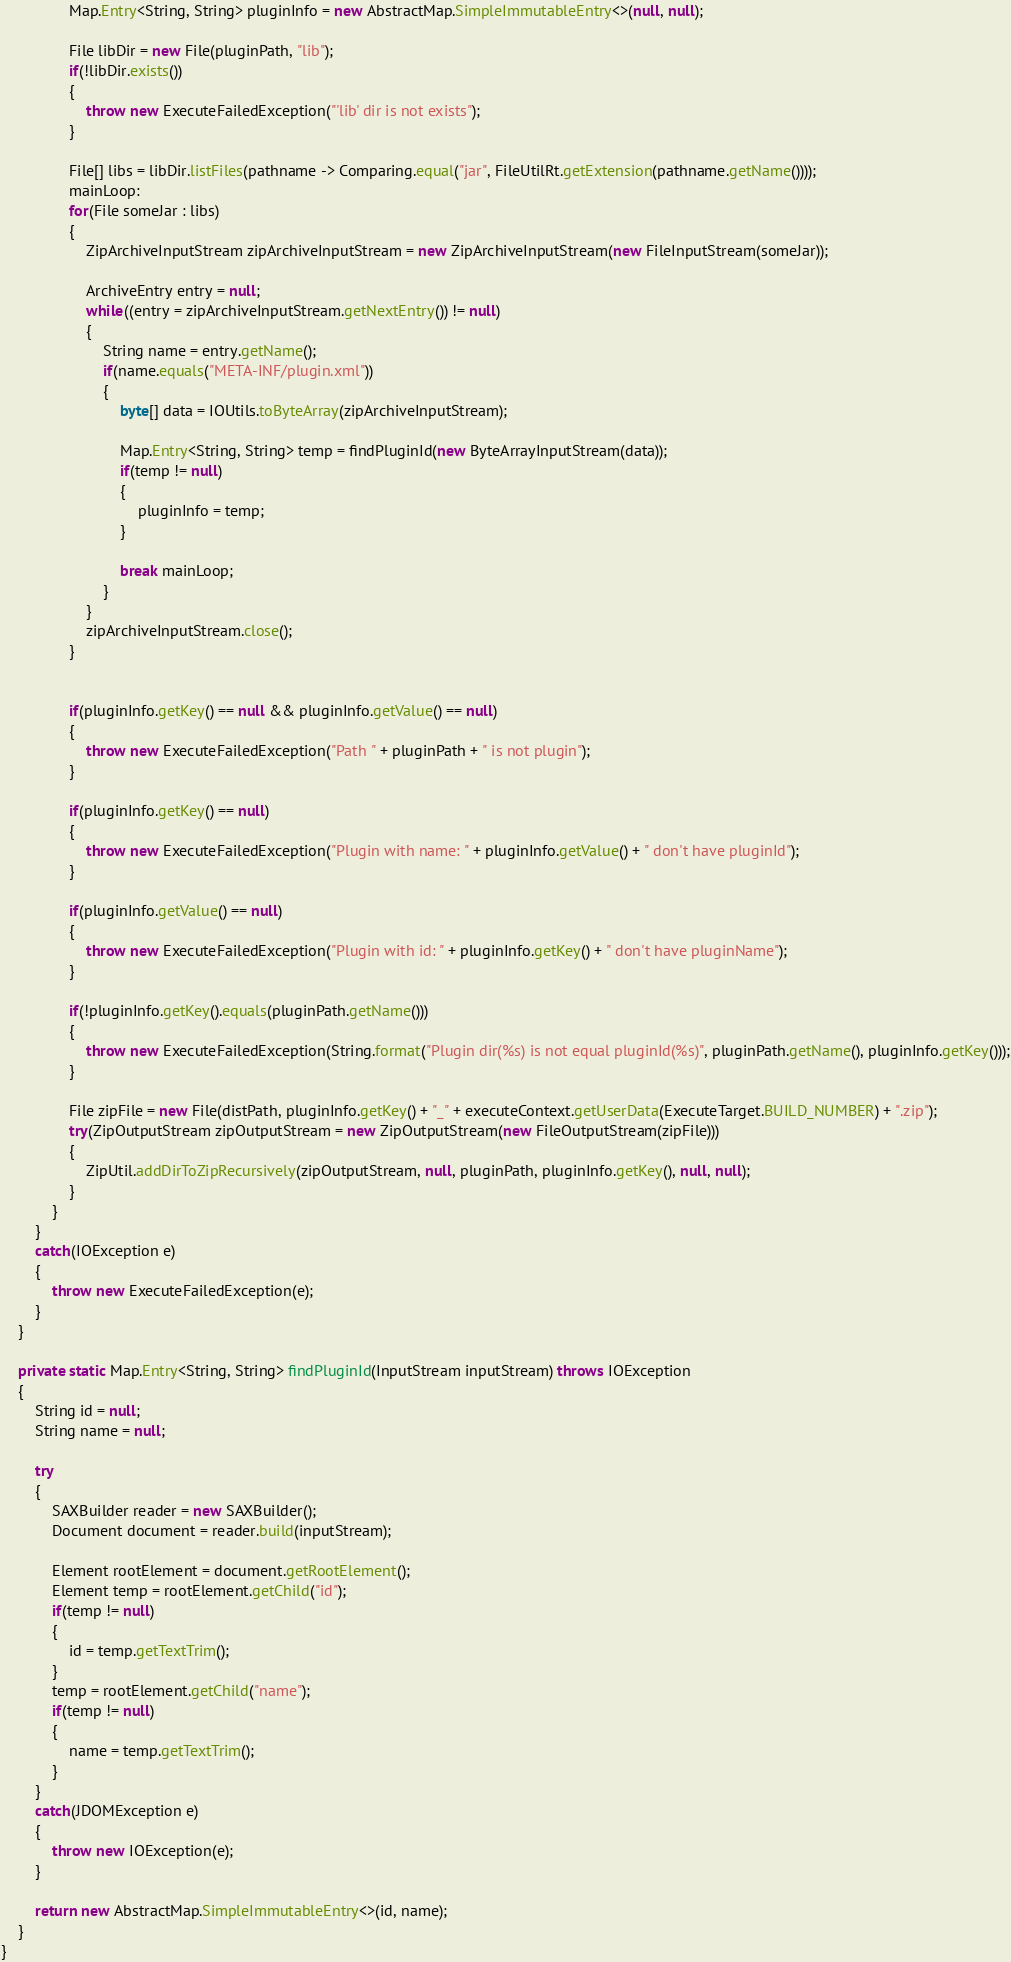<code> <loc_0><loc_0><loc_500><loc_500><_Java_>				Map.Entry<String, String> pluginInfo = new AbstractMap.SimpleImmutableEntry<>(null, null);

				File libDir = new File(pluginPath, "lib");
				if(!libDir.exists())
				{
					throw new ExecuteFailedException("'lib' dir is not exists");
				}

				File[] libs = libDir.listFiles(pathname -> Comparing.equal("jar", FileUtilRt.getExtension(pathname.getName())));
				mainLoop:
				for(File someJar : libs)
				{
					ZipArchiveInputStream zipArchiveInputStream = new ZipArchiveInputStream(new FileInputStream(someJar));

					ArchiveEntry entry = null;
					while((entry = zipArchiveInputStream.getNextEntry()) != null)
					{
						String name = entry.getName();
						if(name.equals("META-INF/plugin.xml"))
						{
							byte[] data = IOUtils.toByteArray(zipArchiveInputStream);

							Map.Entry<String, String> temp = findPluginId(new ByteArrayInputStream(data));
							if(temp != null)
							{
								pluginInfo = temp;
							}

							break mainLoop;
						}
					}
					zipArchiveInputStream.close();
				}


				if(pluginInfo.getKey() == null && pluginInfo.getValue() == null)
				{
					throw new ExecuteFailedException("Path " + pluginPath + " is not plugin");
				}

				if(pluginInfo.getKey() == null)
				{
					throw new ExecuteFailedException("Plugin with name: " + pluginInfo.getValue() + " don't have pluginId");
				}

				if(pluginInfo.getValue() == null)
				{
					throw new ExecuteFailedException("Plugin with id: " + pluginInfo.getKey() + " don't have pluginName");
				}

				if(!pluginInfo.getKey().equals(pluginPath.getName()))
				{
					throw new ExecuteFailedException(String.format("Plugin dir(%s) is not equal pluginId(%s)", pluginPath.getName(), pluginInfo.getKey()));
				}

				File zipFile = new File(distPath, pluginInfo.getKey() + "_" + executeContext.getUserData(ExecuteTarget.BUILD_NUMBER) + ".zip");
				try(ZipOutputStream zipOutputStream = new ZipOutputStream(new FileOutputStream(zipFile)))
				{
					ZipUtil.addDirToZipRecursively(zipOutputStream, null, pluginPath, pluginInfo.getKey(), null, null);
				}
			}
		}
		catch(IOException e)
		{
			throw new ExecuteFailedException(e);
		}
	}

	private static Map.Entry<String, String> findPluginId(InputStream inputStream) throws IOException
	{
		String id = null;
		String name = null;

		try
		{
			SAXBuilder reader = new SAXBuilder();
			Document document = reader.build(inputStream);

			Element rootElement = document.getRootElement();
			Element temp = rootElement.getChild("id");
			if(temp != null)
			{
				id = temp.getTextTrim();
			}
			temp = rootElement.getChild("name");
			if(temp != null)
			{
				name = temp.getTextTrim();
			}
		}
		catch(JDOMException e)
		{
			throw new IOException(e);
		}

		return new AbstractMap.SimpleImmutableEntry<>(id, name);
	}
}
</code> 